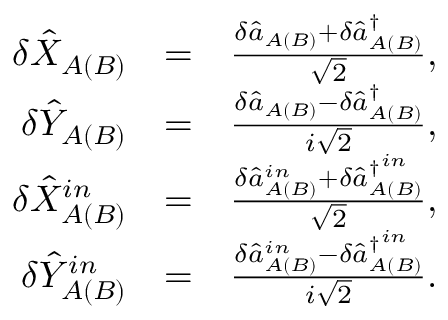<formula> <loc_0><loc_0><loc_500><loc_500>\begin{array} { r l r } { \delta \hat { X } _ { A ( B ) } } & { = } & { \frac { \delta \hat { a } _ { A ( B ) } + \delta \hat { a } _ { A ( B ) } ^ { \dagger } } { \sqrt { 2 } } , } \\ { \delta \hat { Y } _ { A ( B ) } } & { = } & { \frac { \delta \hat { a } _ { A ( B ) } - \delta \hat { a } _ { A ( B ) } ^ { \dagger } } { i \sqrt { 2 } } , } \\ { \delta \hat { X } _ { A ( B ) } ^ { i n } } & { = } & { \frac { \delta \hat { a } _ { A ( B ) } ^ { i n } + \delta \hat { a } _ { A ( B ) } ^ { \dagger ^ { i n } } } { \sqrt { 2 } } , } \\ { \delta \hat { Y } _ { A ( B ) } ^ { i n } } & { = } & { \frac { \delta \hat { a } _ { A ( B ) } ^ { i n } - \delta \hat { a } _ { A ( B ) } ^ { \dagger ^ { i n } } } { i \sqrt { 2 } } . } \end{array}</formula> 